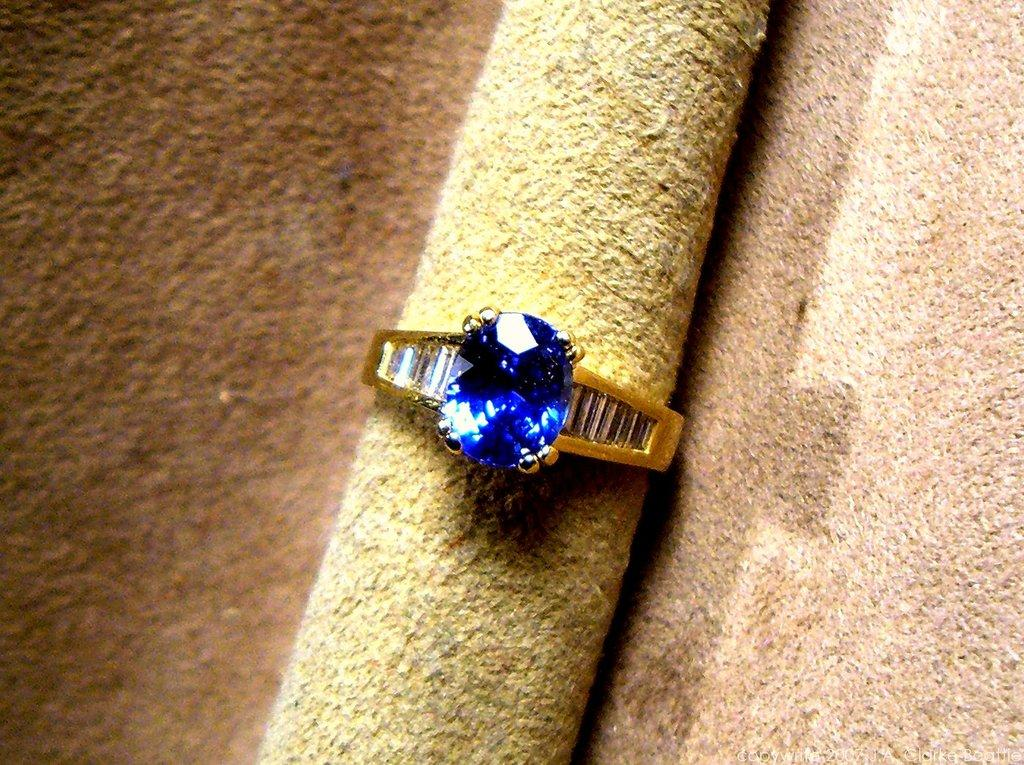What is the main object in the picture? There is a diamond ring in the picture. Where is the diamond ring placed? The diamond ring is placed on a carpet. What is the caption of the picture? There is no caption present in the image, as it is a picture of a diamond ring placed on a carpet. How many stars can be seen in the picture? There are no stars visible in the picture, as it features a diamond ring placed on a carpet. 